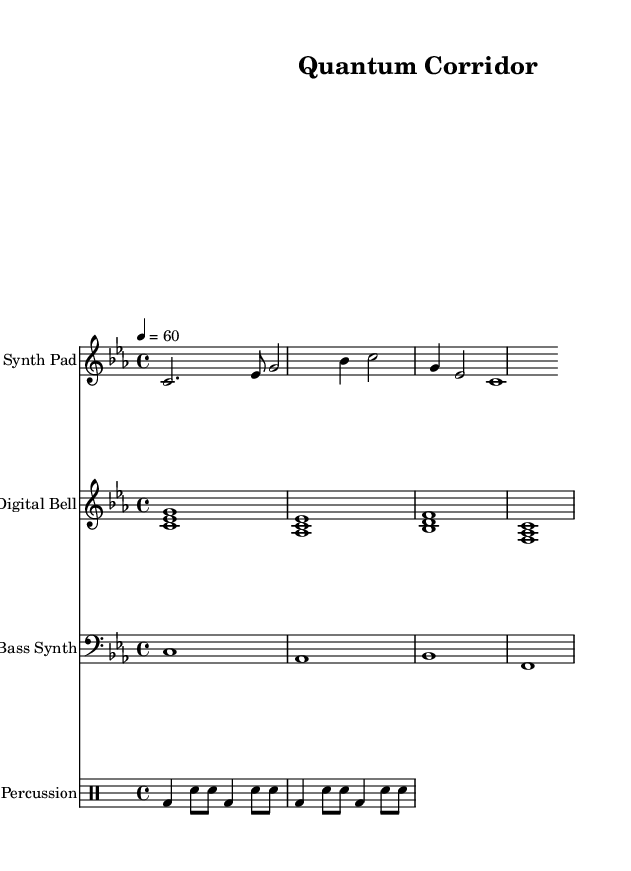What is the key signature of this music? The key signature is indicated at the beginning of the staff. In this case, it shows three flats: B flat, E flat, and A flat, which corresponds to C minor.
Answer: C minor What is the time signature of this music? The time signature is located next to the key signature. It shows a 4 over 4, which means there are four beats in each measure.
Answer: 4/4 What is the tempo marking of this piece? The tempo is noted at the beginning of the score with "4 = 60", indicating that quarter notes are played at a speed of sixty beats per minute.
Answer: 60 How many measures are in the melody section? By counting the distinct groupings of notes in the melody line, we can see there are six measures, each marked by a cluster of notes.
Answer: 6 What instruments are used in this score? The instruments are labeled at the beginning of each staff: Synth Pad for the melody, Digital Bell for harmony, and Bass Synth for the bass line. Furthermore, there is also a Percussion section.
Answer: Synth Pad, Digital Bell, Bass Synth, Percussion Which instrument plays the harmony part? The instrument for the harmony is stated clearly above the staff line, labeled as "Digital Bell".
Answer: Digital Bell What type of rhythm pattern does the percussion section follow? The rhythm pattern in the percussion section consists of a repeating sequence of bass drum and snare drum hits, categorized in eighth notes and quarter notes.
Answer: Bass drum and snare drum 